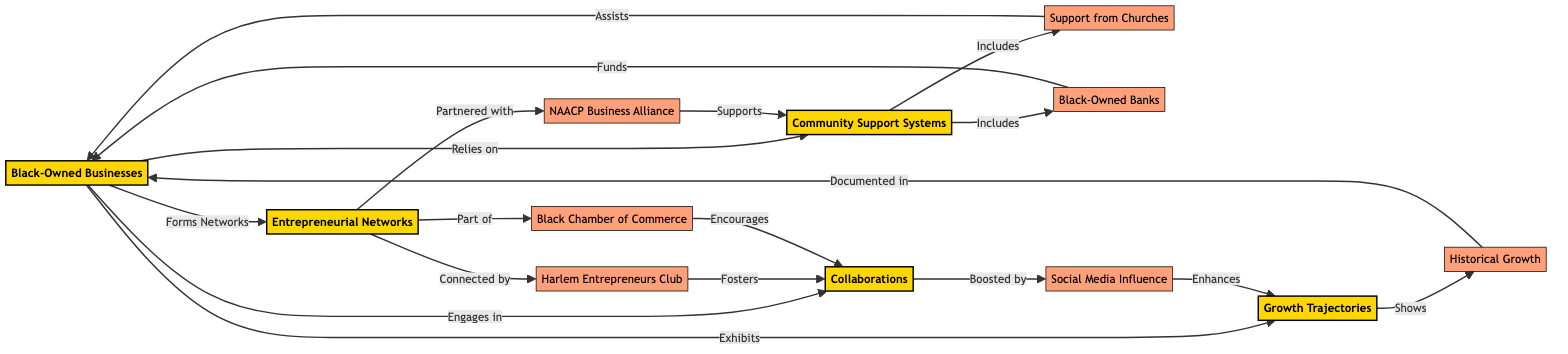What is the total number of nodes in the diagram? The diagram includes 12 nodes, which are entities or concepts represented in the network.
Answer: 12 What type of relationship connects "Black-Owned Businesses" and "Entrepreneurial Networks"? The relationship is indicated by the edge labeled "Forms Networks," showing how these two nodes are directly linked in the network.
Answer: Forms Networks Which node is associated with the "Harlem Entrepreneurs Club"? The "Harlem Entrepreneurs Club" (node 6) is linked to "Entrepreneurial Networks" through the relationship "Connected by."
Answer: Entrepreneurial Networks How many connections does "Community Support Systems" have? "Community Support Systems" has two outgoing connections, one to "Support from Churches" and another to "Black-Owned Banks."
Answer: 2 What supports the node "Collaborations"? The node "Collaborations" is supported by multiple nodes: "Harlem Entrepreneurs Club" (fosters), "Black Chamber of Commerce" (encourages), and "Social Media Influence" (boosted by).
Answer: Harlem Entrepreneurs Club, Black Chamber of Commerce, Social Media Influence Which node assists "Black-Owned Businesses"? The node "Support from Churches" has an edge labeled "Assists," indicating its role in supporting "Black-Owned Businesses."
Answer: Support from Churches What does "Growth Trajectories" exhibit? The node "Growth Trajectories" is directly linked to "Black-Owned Businesses" with an edge labeled "Exhibits," which highlights the manifestation of growth over time.
Answer: Black-Owned Businesses Which node includes financial support for "Black-Owned Businesses"? The node "Black-Owned Banks" provides funds to "Black-Owned Businesses," demonstrating a financial support relationship.
Answer: Funds How does "Social Media Influence" relate to "Growth Trajectories"? "Social Media Influence" enhances "Growth Trajectories," showing the impact of social media on the growth trajectories of black-owned businesses.
Answer: Enhances 